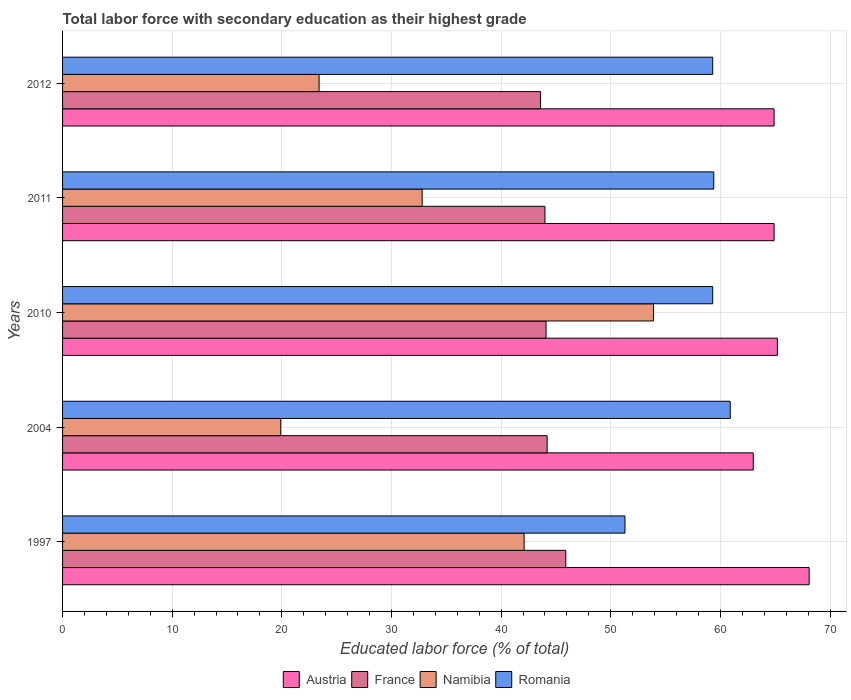Are the number of bars per tick equal to the number of legend labels?
Your response must be concise. Yes. How many bars are there on the 3rd tick from the bottom?
Make the answer very short. 4. What is the percentage of total labor force with primary education in Austria in 2011?
Provide a succinct answer. 64.9. Across all years, what is the maximum percentage of total labor force with primary education in Austria?
Make the answer very short. 68.1. Across all years, what is the minimum percentage of total labor force with primary education in France?
Offer a very short reply. 43.6. What is the total percentage of total labor force with primary education in Austria in the graph?
Provide a short and direct response. 326.1. What is the difference between the percentage of total labor force with primary education in Namibia in 1997 and that in 2004?
Give a very brief answer. 22.2. What is the difference between the percentage of total labor force with primary education in France in 2004 and the percentage of total labor force with primary education in Austria in 2012?
Give a very brief answer. -20.7. What is the average percentage of total labor force with primary education in Romania per year?
Provide a short and direct response. 58.04. In the year 2011, what is the difference between the percentage of total labor force with primary education in Romania and percentage of total labor force with primary education in France?
Provide a short and direct response. 15.4. What is the ratio of the percentage of total labor force with primary education in Romania in 1997 to that in 2011?
Make the answer very short. 0.86. Is the difference between the percentage of total labor force with primary education in Romania in 2004 and 2011 greater than the difference between the percentage of total labor force with primary education in France in 2004 and 2011?
Provide a succinct answer. Yes. What is the difference between the highest and the second highest percentage of total labor force with primary education in Austria?
Keep it short and to the point. 2.9. What is the difference between the highest and the lowest percentage of total labor force with primary education in Romania?
Ensure brevity in your answer.  9.6. In how many years, is the percentage of total labor force with primary education in Namibia greater than the average percentage of total labor force with primary education in Namibia taken over all years?
Provide a succinct answer. 2. What does the 1st bar from the top in 2012 represents?
Give a very brief answer. Romania. Is it the case that in every year, the sum of the percentage of total labor force with primary education in Namibia and percentage of total labor force with primary education in Romania is greater than the percentage of total labor force with primary education in France?
Provide a short and direct response. Yes. How many bars are there?
Provide a short and direct response. 20. How many years are there in the graph?
Ensure brevity in your answer.  5. What is the difference between two consecutive major ticks on the X-axis?
Your answer should be compact. 10. Are the values on the major ticks of X-axis written in scientific E-notation?
Your answer should be very brief. No. Does the graph contain any zero values?
Your answer should be compact. No. Where does the legend appear in the graph?
Provide a short and direct response. Bottom center. What is the title of the graph?
Offer a very short reply. Total labor force with secondary education as their highest grade. Does "Greenland" appear as one of the legend labels in the graph?
Provide a succinct answer. No. What is the label or title of the X-axis?
Provide a short and direct response. Educated labor force (% of total). What is the label or title of the Y-axis?
Provide a short and direct response. Years. What is the Educated labor force (% of total) of Austria in 1997?
Ensure brevity in your answer.  68.1. What is the Educated labor force (% of total) in France in 1997?
Offer a very short reply. 45.9. What is the Educated labor force (% of total) of Namibia in 1997?
Provide a succinct answer. 42.1. What is the Educated labor force (% of total) in Romania in 1997?
Keep it short and to the point. 51.3. What is the Educated labor force (% of total) in France in 2004?
Provide a short and direct response. 44.2. What is the Educated labor force (% of total) in Namibia in 2004?
Your answer should be very brief. 19.9. What is the Educated labor force (% of total) in Romania in 2004?
Make the answer very short. 60.9. What is the Educated labor force (% of total) of Austria in 2010?
Ensure brevity in your answer.  65.2. What is the Educated labor force (% of total) of France in 2010?
Provide a short and direct response. 44.1. What is the Educated labor force (% of total) of Namibia in 2010?
Your response must be concise. 53.9. What is the Educated labor force (% of total) in Romania in 2010?
Ensure brevity in your answer.  59.3. What is the Educated labor force (% of total) in Austria in 2011?
Provide a short and direct response. 64.9. What is the Educated labor force (% of total) in France in 2011?
Your answer should be very brief. 44. What is the Educated labor force (% of total) of Namibia in 2011?
Offer a terse response. 32.8. What is the Educated labor force (% of total) of Romania in 2011?
Provide a succinct answer. 59.4. What is the Educated labor force (% of total) in Austria in 2012?
Make the answer very short. 64.9. What is the Educated labor force (% of total) in France in 2012?
Ensure brevity in your answer.  43.6. What is the Educated labor force (% of total) of Namibia in 2012?
Your answer should be compact. 23.4. What is the Educated labor force (% of total) in Romania in 2012?
Your answer should be compact. 59.3. Across all years, what is the maximum Educated labor force (% of total) in Austria?
Your response must be concise. 68.1. Across all years, what is the maximum Educated labor force (% of total) in France?
Your response must be concise. 45.9. Across all years, what is the maximum Educated labor force (% of total) in Namibia?
Give a very brief answer. 53.9. Across all years, what is the maximum Educated labor force (% of total) of Romania?
Ensure brevity in your answer.  60.9. Across all years, what is the minimum Educated labor force (% of total) of Austria?
Provide a succinct answer. 63. Across all years, what is the minimum Educated labor force (% of total) in France?
Your answer should be very brief. 43.6. Across all years, what is the minimum Educated labor force (% of total) of Namibia?
Make the answer very short. 19.9. Across all years, what is the minimum Educated labor force (% of total) in Romania?
Offer a very short reply. 51.3. What is the total Educated labor force (% of total) of Austria in the graph?
Your answer should be compact. 326.1. What is the total Educated labor force (% of total) of France in the graph?
Provide a succinct answer. 221.8. What is the total Educated labor force (% of total) in Namibia in the graph?
Give a very brief answer. 172.1. What is the total Educated labor force (% of total) of Romania in the graph?
Make the answer very short. 290.2. What is the difference between the Educated labor force (% of total) of Namibia in 1997 and that in 2004?
Provide a succinct answer. 22.2. What is the difference between the Educated labor force (% of total) of France in 1997 and that in 2010?
Provide a short and direct response. 1.8. What is the difference between the Educated labor force (% of total) of Romania in 1997 and that in 2010?
Provide a short and direct response. -8. What is the difference between the Educated labor force (% of total) of France in 1997 and that in 2011?
Keep it short and to the point. 1.9. What is the difference between the Educated labor force (% of total) of Namibia in 1997 and that in 2011?
Provide a short and direct response. 9.3. What is the difference between the Educated labor force (% of total) in France in 1997 and that in 2012?
Your answer should be very brief. 2.3. What is the difference between the Educated labor force (% of total) of Namibia in 1997 and that in 2012?
Give a very brief answer. 18.7. What is the difference between the Educated labor force (% of total) in Romania in 1997 and that in 2012?
Your answer should be very brief. -8. What is the difference between the Educated labor force (% of total) in France in 2004 and that in 2010?
Ensure brevity in your answer.  0.1. What is the difference between the Educated labor force (% of total) in Namibia in 2004 and that in 2010?
Your answer should be compact. -34. What is the difference between the Educated labor force (% of total) of France in 2004 and that in 2011?
Provide a succinct answer. 0.2. What is the difference between the Educated labor force (% of total) in Austria in 2004 and that in 2012?
Offer a very short reply. -1.9. What is the difference between the Educated labor force (% of total) in France in 2004 and that in 2012?
Ensure brevity in your answer.  0.6. What is the difference between the Educated labor force (% of total) in Namibia in 2004 and that in 2012?
Give a very brief answer. -3.5. What is the difference between the Educated labor force (% of total) in Romania in 2004 and that in 2012?
Your answer should be very brief. 1.6. What is the difference between the Educated labor force (% of total) of France in 2010 and that in 2011?
Your answer should be compact. 0.1. What is the difference between the Educated labor force (% of total) of Namibia in 2010 and that in 2011?
Your response must be concise. 21.1. What is the difference between the Educated labor force (% of total) in Austria in 2010 and that in 2012?
Your answer should be compact. 0.3. What is the difference between the Educated labor force (% of total) in France in 2010 and that in 2012?
Your answer should be very brief. 0.5. What is the difference between the Educated labor force (% of total) of Namibia in 2010 and that in 2012?
Make the answer very short. 30.5. What is the difference between the Educated labor force (% of total) of France in 2011 and that in 2012?
Keep it short and to the point. 0.4. What is the difference between the Educated labor force (% of total) in Austria in 1997 and the Educated labor force (% of total) in France in 2004?
Your response must be concise. 23.9. What is the difference between the Educated labor force (% of total) in Austria in 1997 and the Educated labor force (% of total) in Namibia in 2004?
Give a very brief answer. 48.2. What is the difference between the Educated labor force (% of total) in Austria in 1997 and the Educated labor force (% of total) in Romania in 2004?
Offer a very short reply. 7.2. What is the difference between the Educated labor force (% of total) of Namibia in 1997 and the Educated labor force (% of total) of Romania in 2004?
Offer a very short reply. -18.8. What is the difference between the Educated labor force (% of total) of Austria in 1997 and the Educated labor force (% of total) of France in 2010?
Your answer should be very brief. 24. What is the difference between the Educated labor force (% of total) of Austria in 1997 and the Educated labor force (% of total) of Namibia in 2010?
Your answer should be compact. 14.2. What is the difference between the Educated labor force (% of total) in Austria in 1997 and the Educated labor force (% of total) in Romania in 2010?
Offer a terse response. 8.8. What is the difference between the Educated labor force (% of total) of France in 1997 and the Educated labor force (% of total) of Namibia in 2010?
Offer a very short reply. -8. What is the difference between the Educated labor force (% of total) of Namibia in 1997 and the Educated labor force (% of total) of Romania in 2010?
Ensure brevity in your answer.  -17.2. What is the difference between the Educated labor force (% of total) in Austria in 1997 and the Educated labor force (% of total) in France in 2011?
Make the answer very short. 24.1. What is the difference between the Educated labor force (% of total) in Austria in 1997 and the Educated labor force (% of total) in Namibia in 2011?
Offer a very short reply. 35.3. What is the difference between the Educated labor force (% of total) of France in 1997 and the Educated labor force (% of total) of Namibia in 2011?
Give a very brief answer. 13.1. What is the difference between the Educated labor force (% of total) in France in 1997 and the Educated labor force (% of total) in Romania in 2011?
Give a very brief answer. -13.5. What is the difference between the Educated labor force (% of total) in Namibia in 1997 and the Educated labor force (% of total) in Romania in 2011?
Your answer should be compact. -17.3. What is the difference between the Educated labor force (% of total) in Austria in 1997 and the Educated labor force (% of total) in France in 2012?
Your response must be concise. 24.5. What is the difference between the Educated labor force (% of total) in Austria in 1997 and the Educated labor force (% of total) in Namibia in 2012?
Ensure brevity in your answer.  44.7. What is the difference between the Educated labor force (% of total) in France in 1997 and the Educated labor force (% of total) in Namibia in 2012?
Make the answer very short. 22.5. What is the difference between the Educated labor force (% of total) in France in 1997 and the Educated labor force (% of total) in Romania in 2012?
Your answer should be compact. -13.4. What is the difference between the Educated labor force (% of total) in Namibia in 1997 and the Educated labor force (% of total) in Romania in 2012?
Ensure brevity in your answer.  -17.2. What is the difference between the Educated labor force (% of total) in Austria in 2004 and the Educated labor force (% of total) in Namibia in 2010?
Give a very brief answer. 9.1. What is the difference between the Educated labor force (% of total) of France in 2004 and the Educated labor force (% of total) of Romania in 2010?
Your answer should be compact. -15.1. What is the difference between the Educated labor force (% of total) of Namibia in 2004 and the Educated labor force (% of total) of Romania in 2010?
Make the answer very short. -39.4. What is the difference between the Educated labor force (% of total) in Austria in 2004 and the Educated labor force (% of total) in France in 2011?
Offer a terse response. 19. What is the difference between the Educated labor force (% of total) in Austria in 2004 and the Educated labor force (% of total) in Namibia in 2011?
Provide a succinct answer. 30.2. What is the difference between the Educated labor force (% of total) in Austria in 2004 and the Educated labor force (% of total) in Romania in 2011?
Your response must be concise. 3.6. What is the difference between the Educated labor force (% of total) in France in 2004 and the Educated labor force (% of total) in Namibia in 2011?
Provide a short and direct response. 11.4. What is the difference between the Educated labor force (% of total) of France in 2004 and the Educated labor force (% of total) of Romania in 2011?
Keep it short and to the point. -15.2. What is the difference between the Educated labor force (% of total) of Namibia in 2004 and the Educated labor force (% of total) of Romania in 2011?
Offer a very short reply. -39.5. What is the difference between the Educated labor force (% of total) of Austria in 2004 and the Educated labor force (% of total) of Namibia in 2012?
Offer a terse response. 39.6. What is the difference between the Educated labor force (% of total) in Austria in 2004 and the Educated labor force (% of total) in Romania in 2012?
Your response must be concise. 3.7. What is the difference between the Educated labor force (% of total) in France in 2004 and the Educated labor force (% of total) in Namibia in 2012?
Make the answer very short. 20.8. What is the difference between the Educated labor force (% of total) in France in 2004 and the Educated labor force (% of total) in Romania in 2012?
Provide a short and direct response. -15.1. What is the difference between the Educated labor force (% of total) of Namibia in 2004 and the Educated labor force (% of total) of Romania in 2012?
Give a very brief answer. -39.4. What is the difference between the Educated labor force (% of total) of Austria in 2010 and the Educated labor force (% of total) of France in 2011?
Give a very brief answer. 21.2. What is the difference between the Educated labor force (% of total) in Austria in 2010 and the Educated labor force (% of total) in Namibia in 2011?
Provide a short and direct response. 32.4. What is the difference between the Educated labor force (% of total) of Austria in 2010 and the Educated labor force (% of total) of Romania in 2011?
Offer a very short reply. 5.8. What is the difference between the Educated labor force (% of total) in France in 2010 and the Educated labor force (% of total) in Namibia in 2011?
Provide a short and direct response. 11.3. What is the difference between the Educated labor force (% of total) in France in 2010 and the Educated labor force (% of total) in Romania in 2011?
Make the answer very short. -15.3. What is the difference between the Educated labor force (% of total) in Austria in 2010 and the Educated labor force (% of total) in France in 2012?
Offer a terse response. 21.6. What is the difference between the Educated labor force (% of total) of Austria in 2010 and the Educated labor force (% of total) of Namibia in 2012?
Give a very brief answer. 41.8. What is the difference between the Educated labor force (% of total) of Austria in 2010 and the Educated labor force (% of total) of Romania in 2012?
Provide a succinct answer. 5.9. What is the difference between the Educated labor force (% of total) of France in 2010 and the Educated labor force (% of total) of Namibia in 2012?
Provide a succinct answer. 20.7. What is the difference between the Educated labor force (% of total) of France in 2010 and the Educated labor force (% of total) of Romania in 2012?
Your answer should be very brief. -15.2. What is the difference between the Educated labor force (% of total) in Austria in 2011 and the Educated labor force (% of total) in France in 2012?
Your response must be concise. 21.3. What is the difference between the Educated labor force (% of total) in Austria in 2011 and the Educated labor force (% of total) in Namibia in 2012?
Give a very brief answer. 41.5. What is the difference between the Educated labor force (% of total) of France in 2011 and the Educated labor force (% of total) of Namibia in 2012?
Ensure brevity in your answer.  20.6. What is the difference between the Educated labor force (% of total) of France in 2011 and the Educated labor force (% of total) of Romania in 2012?
Provide a short and direct response. -15.3. What is the difference between the Educated labor force (% of total) in Namibia in 2011 and the Educated labor force (% of total) in Romania in 2012?
Offer a terse response. -26.5. What is the average Educated labor force (% of total) in Austria per year?
Make the answer very short. 65.22. What is the average Educated labor force (% of total) in France per year?
Offer a very short reply. 44.36. What is the average Educated labor force (% of total) in Namibia per year?
Make the answer very short. 34.42. What is the average Educated labor force (% of total) in Romania per year?
Make the answer very short. 58.04. In the year 1997, what is the difference between the Educated labor force (% of total) of Austria and Educated labor force (% of total) of France?
Offer a terse response. 22.2. In the year 1997, what is the difference between the Educated labor force (% of total) in Austria and Educated labor force (% of total) in Namibia?
Offer a terse response. 26. In the year 1997, what is the difference between the Educated labor force (% of total) in Austria and Educated labor force (% of total) in Romania?
Provide a short and direct response. 16.8. In the year 1997, what is the difference between the Educated labor force (% of total) in France and Educated labor force (% of total) in Namibia?
Offer a terse response. 3.8. In the year 1997, what is the difference between the Educated labor force (% of total) in Namibia and Educated labor force (% of total) in Romania?
Ensure brevity in your answer.  -9.2. In the year 2004, what is the difference between the Educated labor force (% of total) in Austria and Educated labor force (% of total) in France?
Ensure brevity in your answer.  18.8. In the year 2004, what is the difference between the Educated labor force (% of total) of Austria and Educated labor force (% of total) of Namibia?
Ensure brevity in your answer.  43.1. In the year 2004, what is the difference between the Educated labor force (% of total) in Austria and Educated labor force (% of total) in Romania?
Ensure brevity in your answer.  2.1. In the year 2004, what is the difference between the Educated labor force (% of total) of France and Educated labor force (% of total) of Namibia?
Give a very brief answer. 24.3. In the year 2004, what is the difference between the Educated labor force (% of total) of France and Educated labor force (% of total) of Romania?
Offer a terse response. -16.7. In the year 2004, what is the difference between the Educated labor force (% of total) in Namibia and Educated labor force (% of total) in Romania?
Give a very brief answer. -41. In the year 2010, what is the difference between the Educated labor force (% of total) of Austria and Educated labor force (% of total) of France?
Your answer should be compact. 21.1. In the year 2010, what is the difference between the Educated labor force (% of total) of Austria and Educated labor force (% of total) of Namibia?
Your answer should be very brief. 11.3. In the year 2010, what is the difference between the Educated labor force (% of total) in Austria and Educated labor force (% of total) in Romania?
Your answer should be compact. 5.9. In the year 2010, what is the difference between the Educated labor force (% of total) of France and Educated labor force (% of total) of Romania?
Offer a terse response. -15.2. In the year 2010, what is the difference between the Educated labor force (% of total) of Namibia and Educated labor force (% of total) of Romania?
Offer a very short reply. -5.4. In the year 2011, what is the difference between the Educated labor force (% of total) of Austria and Educated labor force (% of total) of France?
Ensure brevity in your answer.  20.9. In the year 2011, what is the difference between the Educated labor force (% of total) of Austria and Educated labor force (% of total) of Namibia?
Ensure brevity in your answer.  32.1. In the year 2011, what is the difference between the Educated labor force (% of total) of France and Educated labor force (% of total) of Namibia?
Keep it short and to the point. 11.2. In the year 2011, what is the difference between the Educated labor force (% of total) of France and Educated labor force (% of total) of Romania?
Provide a succinct answer. -15.4. In the year 2011, what is the difference between the Educated labor force (% of total) of Namibia and Educated labor force (% of total) of Romania?
Provide a short and direct response. -26.6. In the year 2012, what is the difference between the Educated labor force (% of total) of Austria and Educated labor force (% of total) of France?
Offer a very short reply. 21.3. In the year 2012, what is the difference between the Educated labor force (% of total) of Austria and Educated labor force (% of total) of Namibia?
Ensure brevity in your answer.  41.5. In the year 2012, what is the difference between the Educated labor force (% of total) in Austria and Educated labor force (% of total) in Romania?
Your answer should be compact. 5.6. In the year 2012, what is the difference between the Educated labor force (% of total) of France and Educated labor force (% of total) of Namibia?
Your answer should be very brief. 20.2. In the year 2012, what is the difference between the Educated labor force (% of total) in France and Educated labor force (% of total) in Romania?
Ensure brevity in your answer.  -15.7. In the year 2012, what is the difference between the Educated labor force (% of total) in Namibia and Educated labor force (% of total) in Romania?
Make the answer very short. -35.9. What is the ratio of the Educated labor force (% of total) of Austria in 1997 to that in 2004?
Your answer should be very brief. 1.08. What is the ratio of the Educated labor force (% of total) of France in 1997 to that in 2004?
Offer a terse response. 1.04. What is the ratio of the Educated labor force (% of total) of Namibia in 1997 to that in 2004?
Your answer should be compact. 2.12. What is the ratio of the Educated labor force (% of total) in Romania in 1997 to that in 2004?
Your response must be concise. 0.84. What is the ratio of the Educated labor force (% of total) of Austria in 1997 to that in 2010?
Make the answer very short. 1.04. What is the ratio of the Educated labor force (% of total) of France in 1997 to that in 2010?
Ensure brevity in your answer.  1.04. What is the ratio of the Educated labor force (% of total) in Namibia in 1997 to that in 2010?
Your answer should be compact. 0.78. What is the ratio of the Educated labor force (% of total) of Romania in 1997 to that in 2010?
Your response must be concise. 0.87. What is the ratio of the Educated labor force (% of total) of Austria in 1997 to that in 2011?
Provide a succinct answer. 1.05. What is the ratio of the Educated labor force (% of total) of France in 1997 to that in 2011?
Offer a very short reply. 1.04. What is the ratio of the Educated labor force (% of total) of Namibia in 1997 to that in 2011?
Your response must be concise. 1.28. What is the ratio of the Educated labor force (% of total) in Romania in 1997 to that in 2011?
Give a very brief answer. 0.86. What is the ratio of the Educated labor force (% of total) in Austria in 1997 to that in 2012?
Your answer should be very brief. 1.05. What is the ratio of the Educated labor force (% of total) in France in 1997 to that in 2012?
Give a very brief answer. 1.05. What is the ratio of the Educated labor force (% of total) of Namibia in 1997 to that in 2012?
Keep it short and to the point. 1.8. What is the ratio of the Educated labor force (% of total) in Romania in 1997 to that in 2012?
Offer a very short reply. 0.87. What is the ratio of the Educated labor force (% of total) in Austria in 2004 to that in 2010?
Your answer should be compact. 0.97. What is the ratio of the Educated labor force (% of total) in France in 2004 to that in 2010?
Make the answer very short. 1. What is the ratio of the Educated labor force (% of total) of Namibia in 2004 to that in 2010?
Make the answer very short. 0.37. What is the ratio of the Educated labor force (% of total) of Romania in 2004 to that in 2010?
Your answer should be very brief. 1.03. What is the ratio of the Educated labor force (% of total) of Austria in 2004 to that in 2011?
Give a very brief answer. 0.97. What is the ratio of the Educated labor force (% of total) in Namibia in 2004 to that in 2011?
Make the answer very short. 0.61. What is the ratio of the Educated labor force (% of total) of Romania in 2004 to that in 2011?
Make the answer very short. 1.03. What is the ratio of the Educated labor force (% of total) of Austria in 2004 to that in 2012?
Provide a short and direct response. 0.97. What is the ratio of the Educated labor force (% of total) of France in 2004 to that in 2012?
Provide a succinct answer. 1.01. What is the ratio of the Educated labor force (% of total) in Namibia in 2004 to that in 2012?
Provide a short and direct response. 0.85. What is the ratio of the Educated labor force (% of total) in Romania in 2004 to that in 2012?
Your response must be concise. 1.03. What is the ratio of the Educated labor force (% of total) in Namibia in 2010 to that in 2011?
Keep it short and to the point. 1.64. What is the ratio of the Educated labor force (% of total) in Austria in 2010 to that in 2012?
Your answer should be very brief. 1. What is the ratio of the Educated labor force (% of total) in France in 2010 to that in 2012?
Your answer should be compact. 1.01. What is the ratio of the Educated labor force (% of total) in Namibia in 2010 to that in 2012?
Your answer should be very brief. 2.3. What is the ratio of the Educated labor force (% of total) of France in 2011 to that in 2012?
Your answer should be compact. 1.01. What is the ratio of the Educated labor force (% of total) of Namibia in 2011 to that in 2012?
Offer a terse response. 1.4. What is the difference between the highest and the second highest Educated labor force (% of total) of Austria?
Give a very brief answer. 2.9. What is the difference between the highest and the second highest Educated labor force (% of total) in France?
Your answer should be compact. 1.7. What is the difference between the highest and the second highest Educated labor force (% of total) of Namibia?
Ensure brevity in your answer.  11.8. What is the difference between the highest and the lowest Educated labor force (% of total) of France?
Provide a succinct answer. 2.3. What is the difference between the highest and the lowest Educated labor force (% of total) of Namibia?
Your answer should be very brief. 34. 